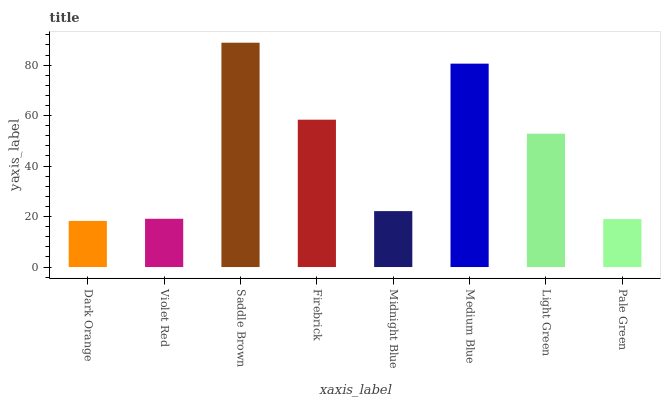Is Violet Red the minimum?
Answer yes or no. No. Is Violet Red the maximum?
Answer yes or no. No. Is Violet Red greater than Dark Orange?
Answer yes or no. Yes. Is Dark Orange less than Violet Red?
Answer yes or no. Yes. Is Dark Orange greater than Violet Red?
Answer yes or no. No. Is Violet Red less than Dark Orange?
Answer yes or no. No. Is Light Green the high median?
Answer yes or no. Yes. Is Midnight Blue the low median?
Answer yes or no. Yes. Is Firebrick the high median?
Answer yes or no. No. Is Saddle Brown the low median?
Answer yes or no. No. 